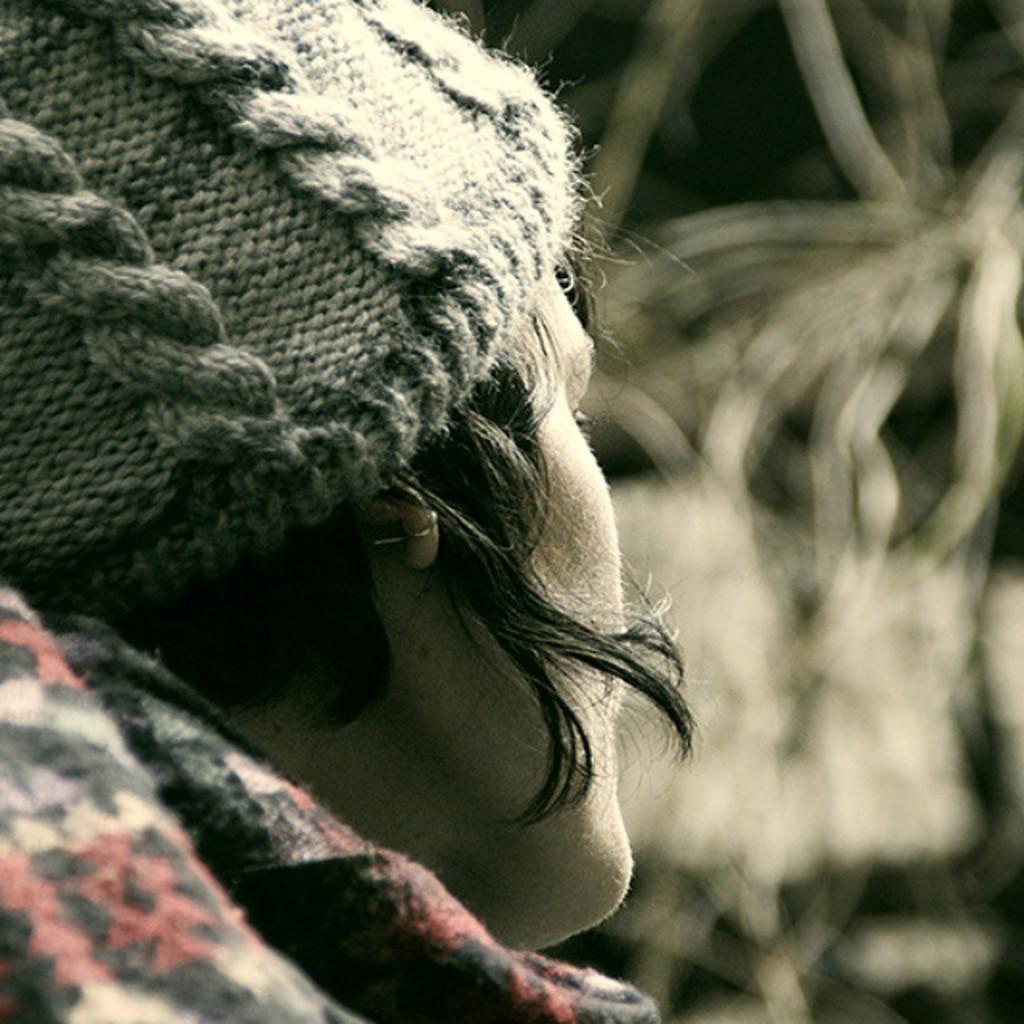Could you give a brief overview of what you see in this image? This is an edited image and here we can see a person wearing cap and coat and the background is blurry. 